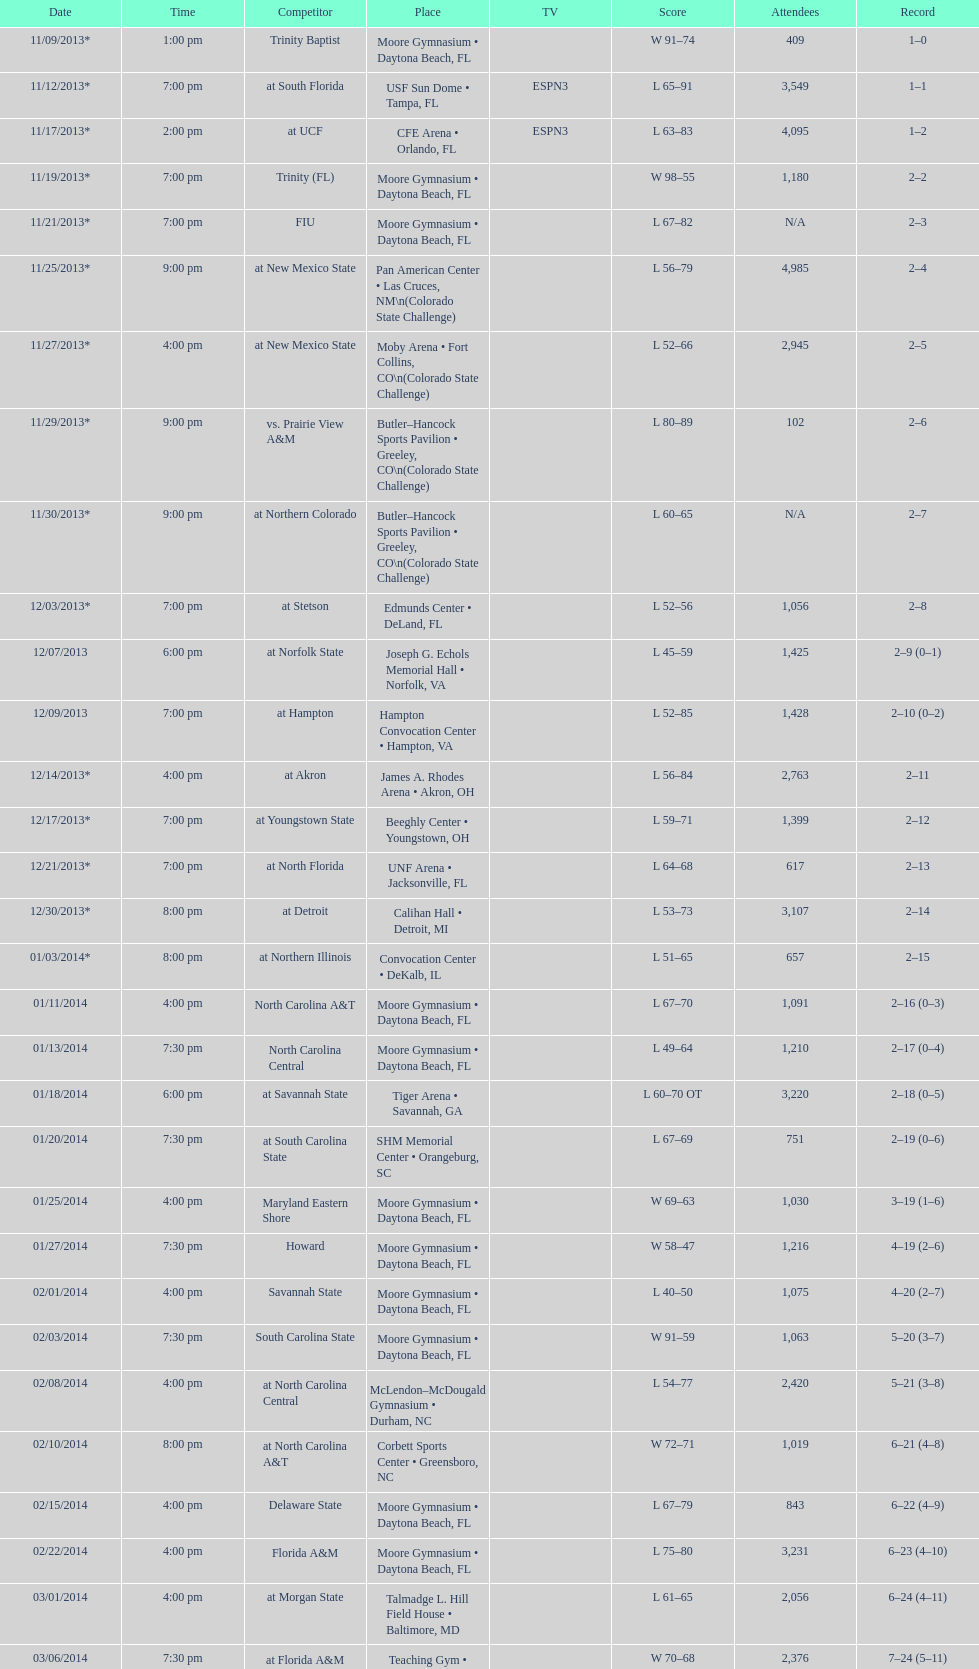What is the total attendance on 11/09/2013? 409. 